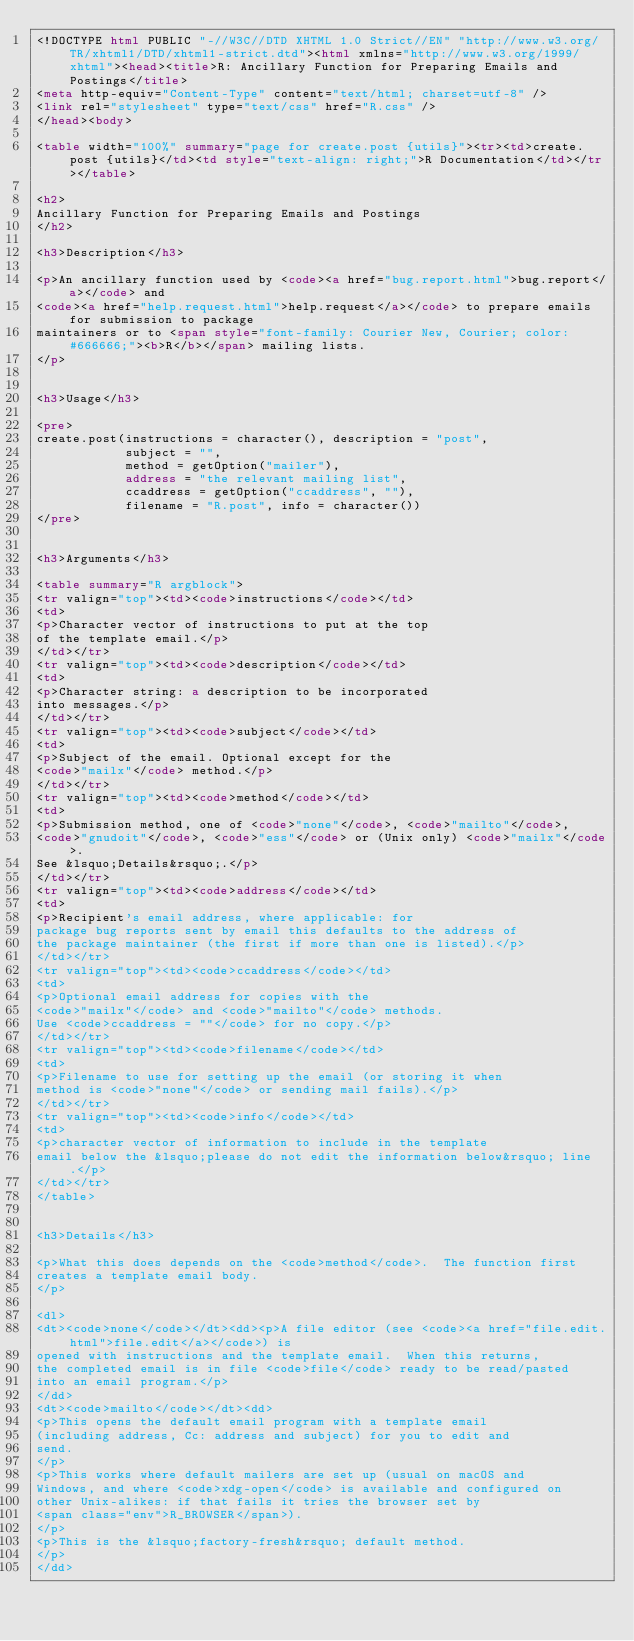Convert code to text. <code><loc_0><loc_0><loc_500><loc_500><_HTML_><!DOCTYPE html PUBLIC "-//W3C//DTD XHTML 1.0 Strict//EN" "http://www.w3.org/TR/xhtml1/DTD/xhtml1-strict.dtd"><html xmlns="http://www.w3.org/1999/xhtml"><head><title>R: Ancillary Function for Preparing Emails and Postings</title>
<meta http-equiv="Content-Type" content="text/html; charset=utf-8" />
<link rel="stylesheet" type="text/css" href="R.css" />
</head><body>

<table width="100%" summary="page for create.post {utils}"><tr><td>create.post {utils}</td><td style="text-align: right;">R Documentation</td></tr></table>

<h2>
Ancillary Function for Preparing Emails and Postings
</h2>

<h3>Description</h3>

<p>An ancillary function used by <code><a href="bug.report.html">bug.report</a></code> and
<code><a href="help.request.html">help.request</a></code> to prepare emails for submission to package
maintainers or to <span style="font-family: Courier New, Courier; color: #666666;"><b>R</b></span> mailing lists.
</p>


<h3>Usage</h3>

<pre>
create.post(instructions = character(), description = "post",
            subject = "",
            method = getOption("mailer"),
            address = "the relevant mailing list",
            ccaddress = getOption("ccaddress", ""),
            filename = "R.post", info = character())
</pre>


<h3>Arguments</h3>

<table summary="R argblock">
<tr valign="top"><td><code>instructions</code></td>
<td>
<p>Character vector of instructions to put at the top
of the template email.</p>
</td></tr>
<tr valign="top"><td><code>description</code></td>
<td>
<p>Character string: a description to be incorporated
into messages.</p>
</td></tr>
<tr valign="top"><td><code>subject</code></td>
<td>
<p>Subject of the email. Optional except for the
<code>"mailx"</code> method.</p>
</td></tr>
<tr valign="top"><td><code>method</code></td>
<td>
<p>Submission method, one of <code>"none"</code>, <code>"mailto"</code>,
<code>"gnudoit"</code>, <code>"ess"</code> or (Unix only) <code>"mailx"</code>.
See &lsquo;Details&rsquo;.</p>
</td></tr>
<tr valign="top"><td><code>address</code></td>
<td>
<p>Recipient's email address, where applicable: for
package bug reports sent by email this defaults to the address of
the package maintainer (the first if more than one is listed).</p>
</td></tr>
<tr valign="top"><td><code>ccaddress</code></td>
<td>
<p>Optional email address for copies with the
<code>"mailx"</code> and <code>"mailto"</code> methods.
Use <code>ccaddress = ""</code> for no copy.</p>
</td></tr>
<tr valign="top"><td><code>filename</code></td>
<td>
<p>Filename to use for setting up the email (or storing it when
method is <code>"none"</code> or sending mail fails).</p>
</td></tr>
<tr valign="top"><td><code>info</code></td>
<td>
<p>character vector of information to include in the template
email below the &lsquo;please do not edit the information below&rsquo; line.</p>
</td></tr>
</table>


<h3>Details</h3>

<p>What this does depends on the <code>method</code>.  The function first
creates a template email body.
</p>

<dl>
<dt><code>none</code></dt><dd><p>A file editor (see <code><a href="file.edit.html">file.edit</a></code>) is
opened with instructions and the template email.  When this returns,
the completed email is in file <code>file</code> ready to be read/pasted
into an email program.</p>
</dd>
<dt><code>mailto</code></dt><dd>
<p>This opens the default email program with a template email
(including address, Cc: address and subject) for you to edit and
send.
</p>
<p>This works where default mailers are set up (usual on macOS and
Windows, and where <code>xdg-open</code> is available and configured on
other Unix-alikes: if that fails it tries the browser set by
<span class="env">R_BROWSER</span>).
</p>
<p>This is the &lsquo;factory-fresh&rsquo; default method.
</p>
</dd></code> 